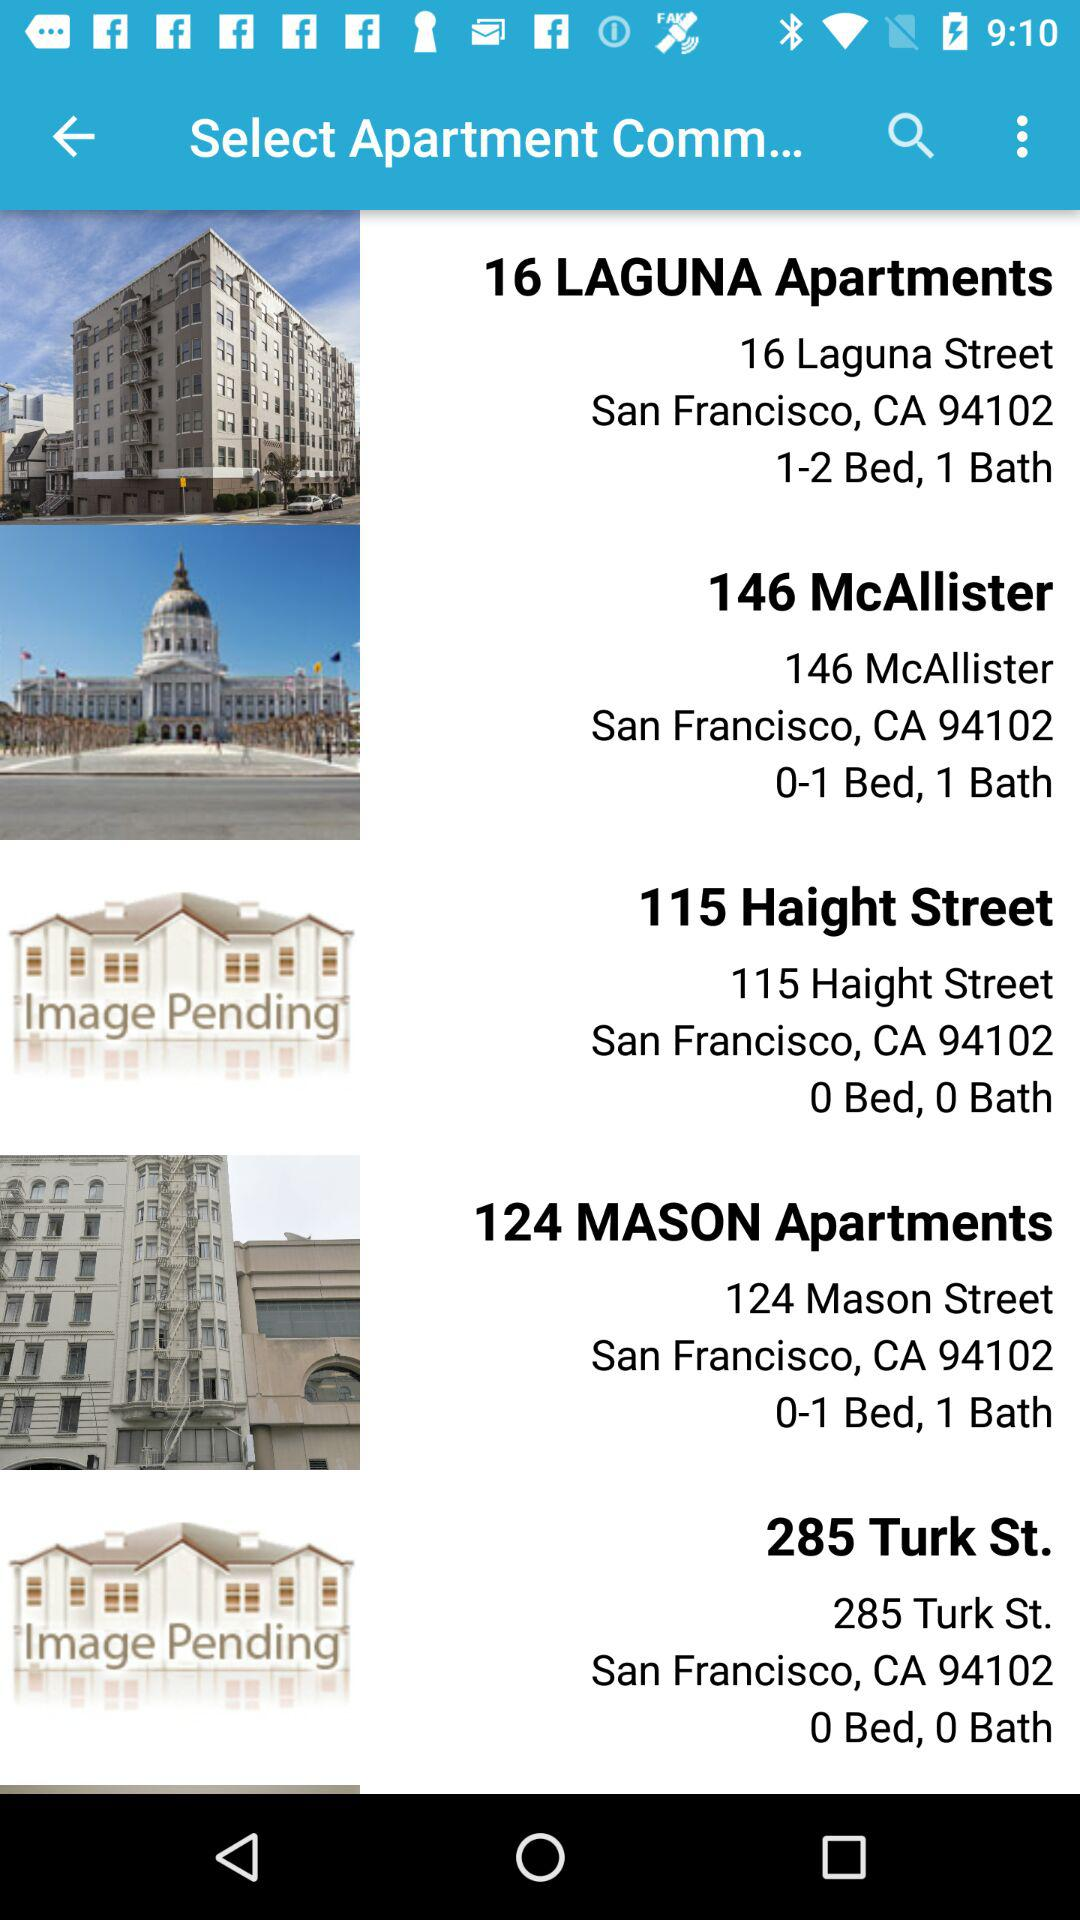What is the address of the 285 Turk St. apartment? The address of the 285 Turk St. apartment is 285 Turk St., San Francisco, CA 94102. 